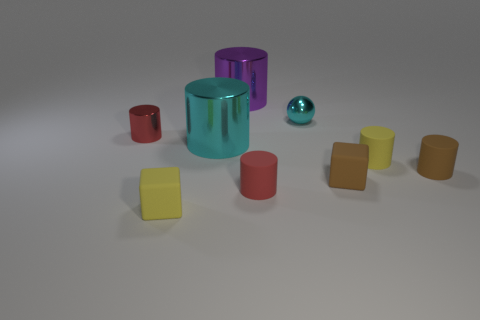Subtract all red cylinders. How many cylinders are left? 4 Subtract all cyan shiny cylinders. How many cylinders are left? 5 Subtract 4 cylinders. How many cylinders are left? 2 Subtract all green cylinders. Subtract all purple blocks. How many cylinders are left? 6 Add 1 tiny blue metal balls. How many objects exist? 10 Subtract all spheres. How many objects are left? 8 Add 2 small yellow cylinders. How many small yellow cylinders are left? 3 Add 8 big cyan shiny cylinders. How many big cyan shiny cylinders exist? 9 Subtract 0 purple cubes. How many objects are left? 9 Subtract all cyan metal things. Subtract all small things. How many objects are left? 0 